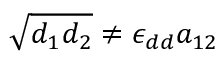<formula> <loc_0><loc_0><loc_500><loc_500>\sqrt { d _ { 1 } d _ { 2 } } \neq \epsilon _ { d d } a _ { 1 2 }</formula> 